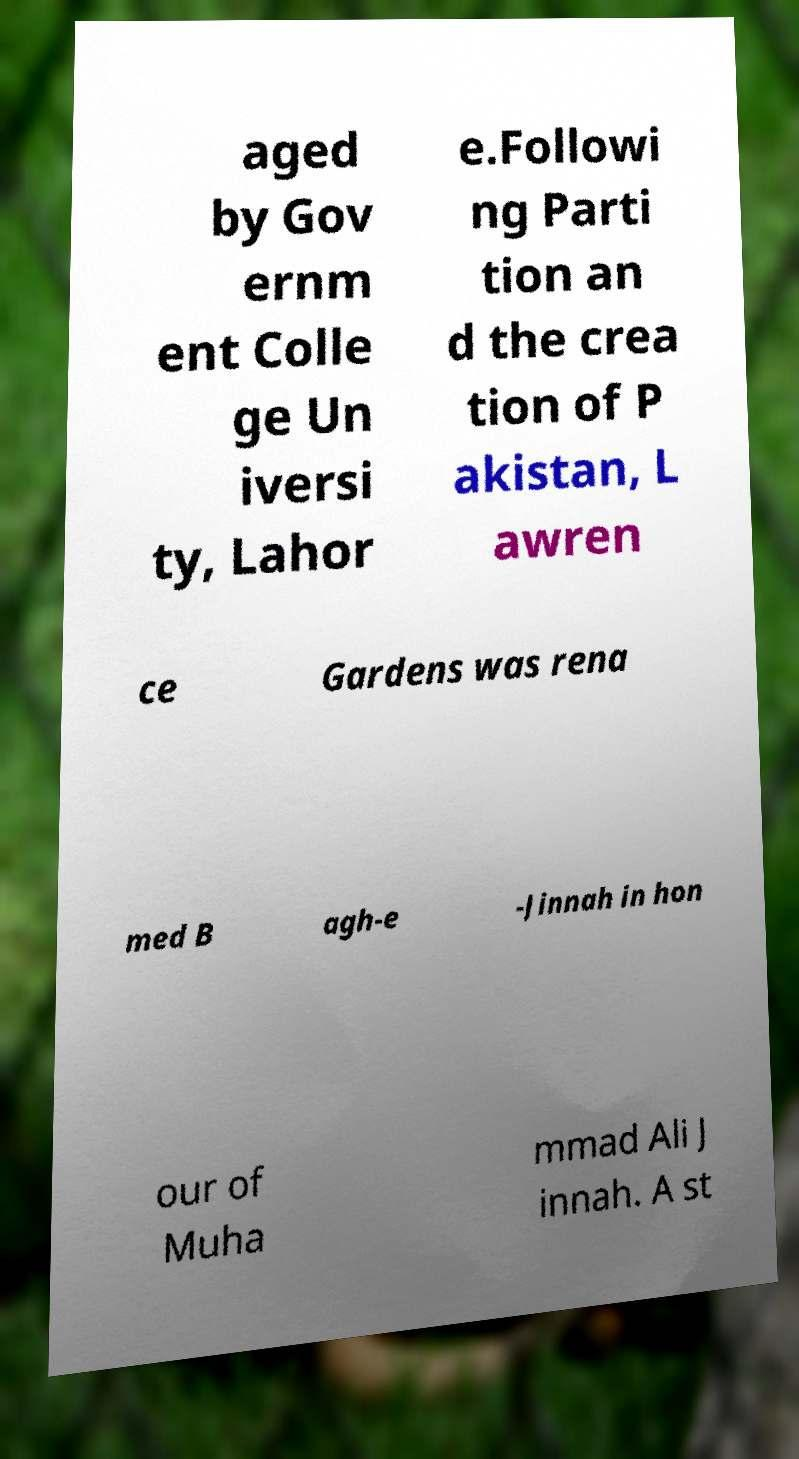Please identify and transcribe the text found in this image. aged by Gov ernm ent Colle ge Un iversi ty, Lahor e.Followi ng Parti tion an d the crea tion of P akistan, L awren ce Gardens was rena med B agh-e -Jinnah in hon our of Muha mmad Ali J innah. A st 